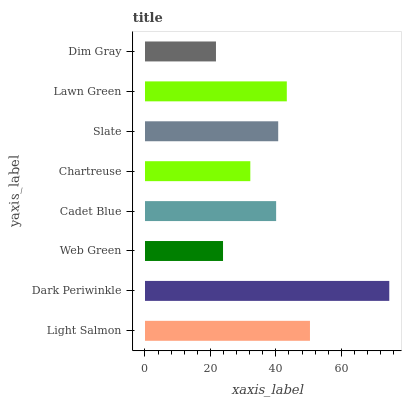Is Dim Gray the minimum?
Answer yes or no. Yes. Is Dark Periwinkle the maximum?
Answer yes or no. Yes. Is Web Green the minimum?
Answer yes or no. No. Is Web Green the maximum?
Answer yes or no. No. Is Dark Periwinkle greater than Web Green?
Answer yes or no. Yes. Is Web Green less than Dark Periwinkle?
Answer yes or no. Yes. Is Web Green greater than Dark Periwinkle?
Answer yes or no. No. Is Dark Periwinkle less than Web Green?
Answer yes or no. No. Is Slate the high median?
Answer yes or no. Yes. Is Cadet Blue the low median?
Answer yes or no. Yes. Is Dim Gray the high median?
Answer yes or no. No. Is Slate the low median?
Answer yes or no. No. 